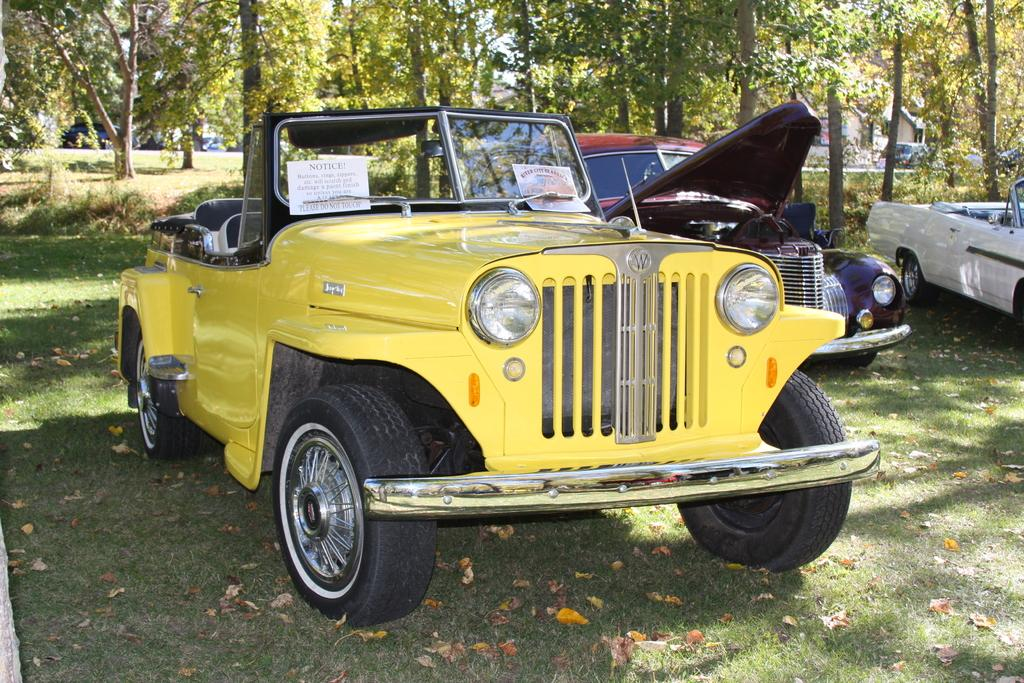What types of objects are present in the image? There are vehicles in the image. What is the ground surface like in the image? There is grass on the ground in the image. What can be seen in the distance in the image? There are trees in the background of the image. What is displayed on the vehicles in the image? There are posters on the vehicles. How does the insect help with the distribution of the posters in the image? There is no insect present in the image, and therefore it cannot help with the distribution of the posters. 